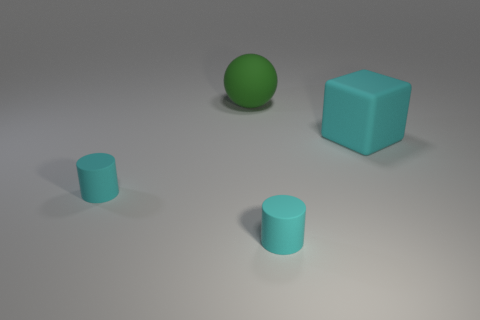Add 2 cyan cubes. How many objects exist? 6 Subtract 2 cylinders. How many cylinders are left? 0 Subtract all large cyan things. Subtract all small brown metal objects. How many objects are left? 3 Add 1 tiny cyan cylinders. How many tiny cyan cylinders are left? 3 Add 1 cyan objects. How many cyan objects exist? 4 Subtract 0 red cylinders. How many objects are left? 4 Subtract all blocks. How many objects are left? 3 Subtract all red balls. Subtract all green cubes. How many balls are left? 1 